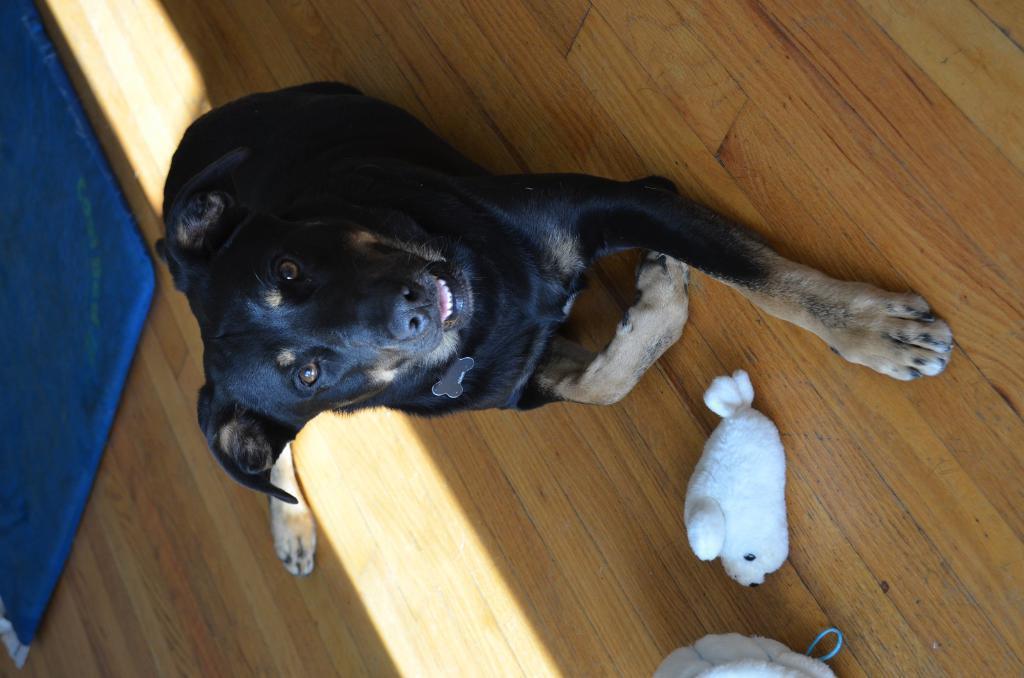Could you give a brief overview of what you see in this image? This image is taken outdoors. At the bottom of the image there is a floor and there are two toys on the floor. On the left side of the image there is a mat on the floor. In the middle of the image there is a dog on the floor. 